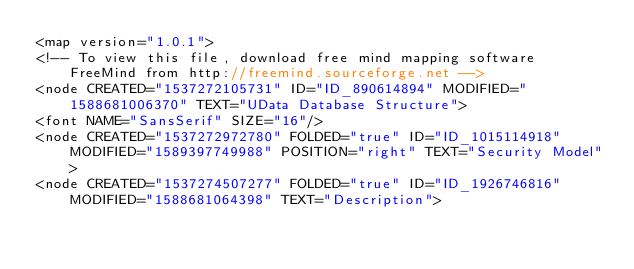<code> <loc_0><loc_0><loc_500><loc_500><_ObjectiveC_><map version="1.0.1">
<!-- To view this file, download free mind mapping software FreeMind from http://freemind.sourceforge.net -->
<node CREATED="1537272105731" ID="ID_890614894" MODIFIED="1588681006370" TEXT="UData Database Structure">
<font NAME="SansSerif" SIZE="16"/>
<node CREATED="1537272972780" FOLDED="true" ID="ID_1015114918" MODIFIED="1589397749988" POSITION="right" TEXT="Security Model">
<node CREATED="1537274507277" FOLDED="true" ID="ID_1926746816" MODIFIED="1588681064398" TEXT="Description"></code> 